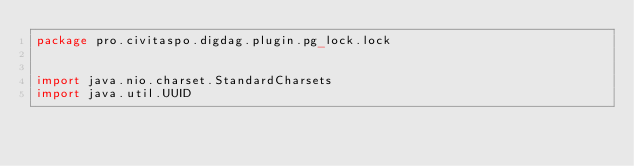Convert code to text. <code><loc_0><loc_0><loc_500><loc_500><_Scala_>package pro.civitaspo.digdag.plugin.pg_lock.lock


import java.nio.charset.StandardCharsets
import java.util.UUID
</code> 